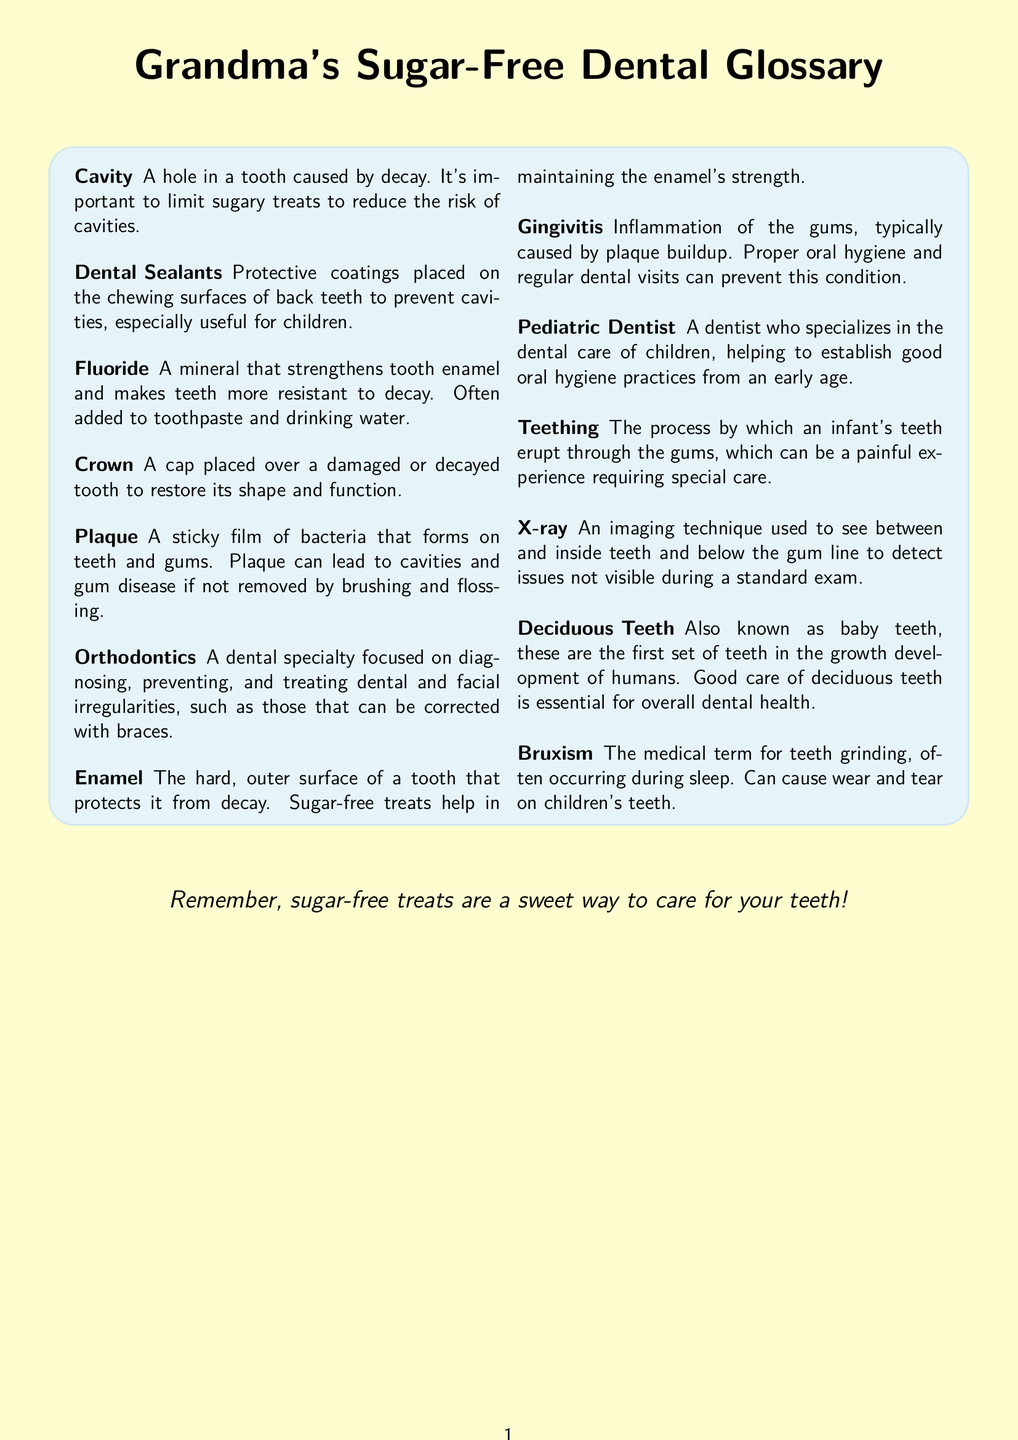What is a cavity? A cavity is defined in the glossary as a hole in a tooth caused by decay.
Answer: A hole in a tooth caused by decay What do dental sealants do? The glossary states that dental sealants provide protective coatings placed on the chewing surfaces of back teeth to prevent cavities.
Answer: Prevent cavities What does fluoride do? The document describes fluoride as a mineral that strengthens tooth enamel and makes teeth more resistant to decay.
Answer: Strengthens tooth enamel Who is a pediatric dentist? According to the glossary, a pediatric dentist is a dentist who specializes in the dental care of children.
Answer: A dentist who specializes in the dental care of children What is bruxism? In the glossary, bruxism is identified as the medical term for teeth grinding.
Answer: The medical term for teeth grinding How do sugar-free treats help teeth? The glossary mentions that sugar-free treats help in maintaining the enamel's strength.
Answer: Maintaining the enamel's strength What is teething? Teething is defined in the glossary as the process by which an infant's teeth erupt through the gums.
Answer: The process by which an infant's teeth erupt through the gums What are deciduous teeth? Deciduous teeth are described in the document as the first set of teeth in the growth development of humans.
Answer: The first set of teeth in the growth development of humans What is gingivitis? The glossary explains that gingivitis is inflammation of the gums, typically caused by plaque buildup.
Answer: Inflammation of the gums 